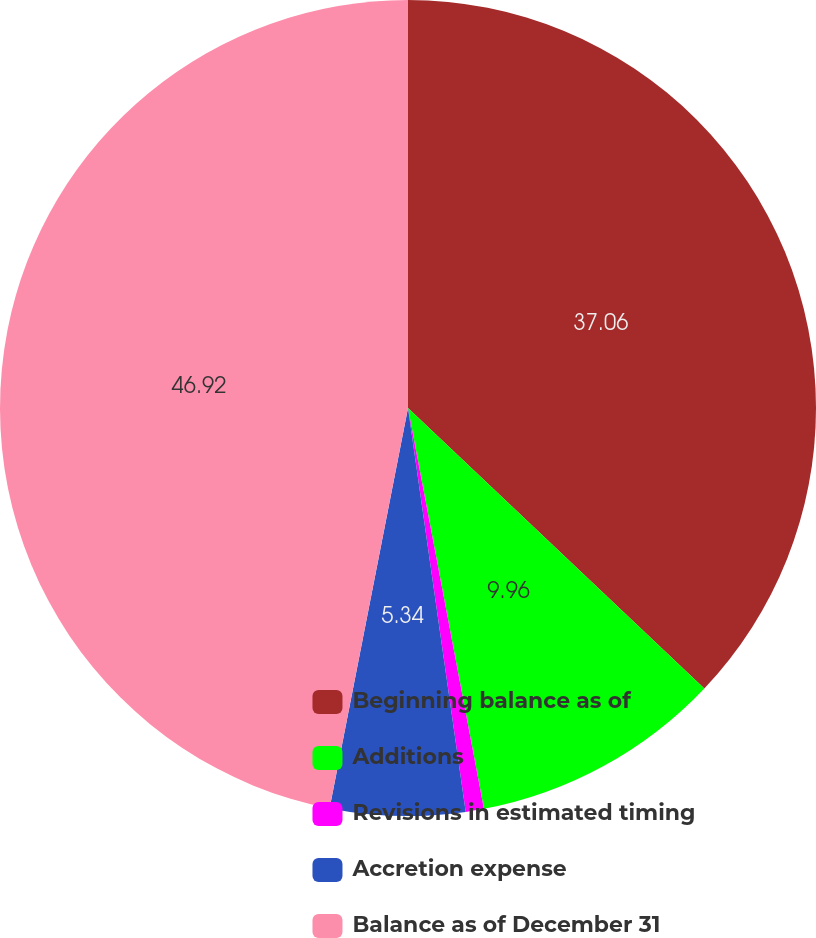Convert chart. <chart><loc_0><loc_0><loc_500><loc_500><pie_chart><fcel>Beginning balance as of<fcel>Additions<fcel>Revisions in estimated timing<fcel>Accretion expense<fcel>Balance as of December 31<nl><fcel>37.07%<fcel>9.96%<fcel>0.72%<fcel>5.34%<fcel>46.93%<nl></chart> 